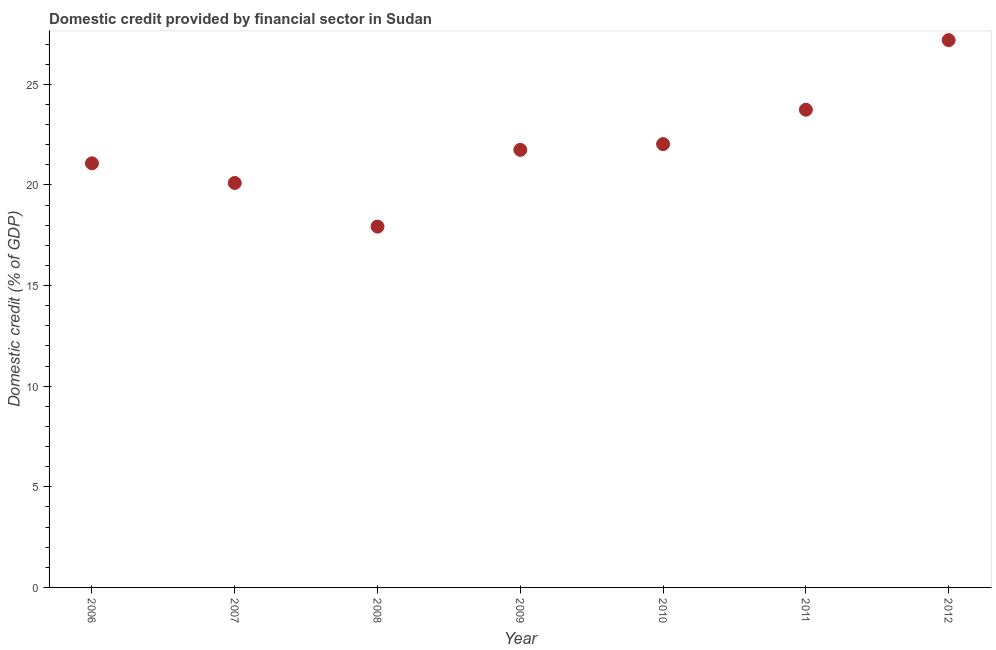What is the domestic credit provided by financial sector in 2010?
Make the answer very short. 22.03. Across all years, what is the maximum domestic credit provided by financial sector?
Your answer should be compact. 27.2. Across all years, what is the minimum domestic credit provided by financial sector?
Ensure brevity in your answer.  17.93. In which year was the domestic credit provided by financial sector maximum?
Provide a short and direct response. 2012. In which year was the domestic credit provided by financial sector minimum?
Provide a short and direct response. 2008. What is the sum of the domestic credit provided by financial sector?
Your answer should be compact. 153.82. What is the difference between the domestic credit provided by financial sector in 2006 and 2008?
Your answer should be compact. 3.14. What is the average domestic credit provided by financial sector per year?
Make the answer very short. 21.97. What is the median domestic credit provided by financial sector?
Make the answer very short. 21.75. What is the ratio of the domestic credit provided by financial sector in 2009 to that in 2011?
Provide a succinct answer. 0.92. Is the difference between the domestic credit provided by financial sector in 2006 and 2007 greater than the difference between any two years?
Offer a very short reply. No. What is the difference between the highest and the second highest domestic credit provided by financial sector?
Offer a terse response. 3.46. Is the sum of the domestic credit provided by financial sector in 2006 and 2009 greater than the maximum domestic credit provided by financial sector across all years?
Your answer should be compact. Yes. What is the difference between the highest and the lowest domestic credit provided by financial sector?
Make the answer very short. 9.27. What is the difference between two consecutive major ticks on the Y-axis?
Your answer should be compact. 5. What is the title of the graph?
Keep it short and to the point. Domestic credit provided by financial sector in Sudan. What is the label or title of the Y-axis?
Give a very brief answer. Domestic credit (% of GDP). What is the Domestic credit (% of GDP) in 2006?
Provide a short and direct response. 21.08. What is the Domestic credit (% of GDP) in 2007?
Offer a very short reply. 20.1. What is the Domestic credit (% of GDP) in 2008?
Ensure brevity in your answer.  17.93. What is the Domestic credit (% of GDP) in 2009?
Keep it short and to the point. 21.75. What is the Domestic credit (% of GDP) in 2010?
Ensure brevity in your answer.  22.03. What is the Domestic credit (% of GDP) in 2011?
Make the answer very short. 23.74. What is the Domestic credit (% of GDP) in 2012?
Provide a succinct answer. 27.2. What is the difference between the Domestic credit (% of GDP) in 2006 and 2007?
Ensure brevity in your answer.  0.97. What is the difference between the Domestic credit (% of GDP) in 2006 and 2008?
Make the answer very short. 3.14. What is the difference between the Domestic credit (% of GDP) in 2006 and 2009?
Ensure brevity in your answer.  -0.67. What is the difference between the Domestic credit (% of GDP) in 2006 and 2010?
Keep it short and to the point. -0.96. What is the difference between the Domestic credit (% of GDP) in 2006 and 2011?
Keep it short and to the point. -2.67. What is the difference between the Domestic credit (% of GDP) in 2006 and 2012?
Provide a succinct answer. -6.12. What is the difference between the Domestic credit (% of GDP) in 2007 and 2008?
Your answer should be compact. 2.17. What is the difference between the Domestic credit (% of GDP) in 2007 and 2009?
Keep it short and to the point. -1.64. What is the difference between the Domestic credit (% of GDP) in 2007 and 2010?
Make the answer very short. -1.93. What is the difference between the Domestic credit (% of GDP) in 2007 and 2011?
Give a very brief answer. -3.64. What is the difference between the Domestic credit (% of GDP) in 2007 and 2012?
Your answer should be compact. -7.1. What is the difference between the Domestic credit (% of GDP) in 2008 and 2009?
Offer a terse response. -3.81. What is the difference between the Domestic credit (% of GDP) in 2008 and 2010?
Offer a very short reply. -4.1. What is the difference between the Domestic credit (% of GDP) in 2008 and 2011?
Make the answer very short. -5.81. What is the difference between the Domestic credit (% of GDP) in 2008 and 2012?
Offer a terse response. -9.27. What is the difference between the Domestic credit (% of GDP) in 2009 and 2010?
Your answer should be very brief. -0.28. What is the difference between the Domestic credit (% of GDP) in 2009 and 2011?
Make the answer very short. -1.99. What is the difference between the Domestic credit (% of GDP) in 2009 and 2012?
Offer a terse response. -5.45. What is the difference between the Domestic credit (% of GDP) in 2010 and 2011?
Ensure brevity in your answer.  -1.71. What is the difference between the Domestic credit (% of GDP) in 2010 and 2012?
Keep it short and to the point. -5.17. What is the difference between the Domestic credit (% of GDP) in 2011 and 2012?
Give a very brief answer. -3.46. What is the ratio of the Domestic credit (% of GDP) in 2006 to that in 2007?
Your answer should be compact. 1.05. What is the ratio of the Domestic credit (% of GDP) in 2006 to that in 2008?
Your answer should be very brief. 1.18. What is the ratio of the Domestic credit (% of GDP) in 2006 to that in 2009?
Keep it short and to the point. 0.97. What is the ratio of the Domestic credit (% of GDP) in 2006 to that in 2011?
Provide a short and direct response. 0.89. What is the ratio of the Domestic credit (% of GDP) in 2006 to that in 2012?
Give a very brief answer. 0.78. What is the ratio of the Domestic credit (% of GDP) in 2007 to that in 2008?
Provide a short and direct response. 1.12. What is the ratio of the Domestic credit (% of GDP) in 2007 to that in 2009?
Offer a very short reply. 0.92. What is the ratio of the Domestic credit (% of GDP) in 2007 to that in 2010?
Offer a very short reply. 0.91. What is the ratio of the Domestic credit (% of GDP) in 2007 to that in 2011?
Your answer should be compact. 0.85. What is the ratio of the Domestic credit (% of GDP) in 2007 to that in 2012?
Your response must be concise. 0.74. What is the ratio of the Domestic credit (% of GDP) in 2008 to that in 2009?
Your answer should be very brief. 0.82. What is the ratio of the Domestic credit (% of GDP) in 2008 to that in 2010?
Offer a very short reply. 0.81. What is the ratio of the Domestic credit (% of GDP) in 2008 to that in 2011?
Offer a terse response. 0.76. What is the ratio of the Domestic credit (% of GDP) in 2008 to that in 2012?
Give a very brief answer. 0.66. What is the ratio of the Domestic credit (% of GDP) in 2009 to that in 2011?
Your answer should be compact. 0.92. What is the ratio of the Domestic credit (% of GDP) in 2010 to that in 2011?
Give a very brief answer. 0.93. What is the ratio of the Domestic credit (% of GDP) in 2010 to that in 2012?
Provide a succinct answer. 0.81. What is the ratio of the Domestic credit (% of GDP) in 2011 to that in 2012?
Make the answer very short. 0.87. 